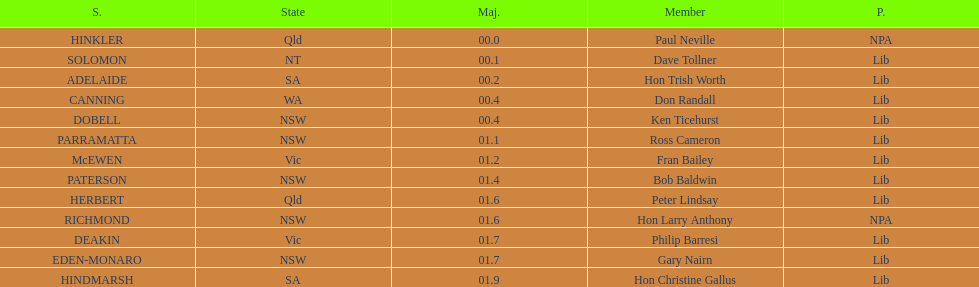How many states were accounted for in the seats? 6. 